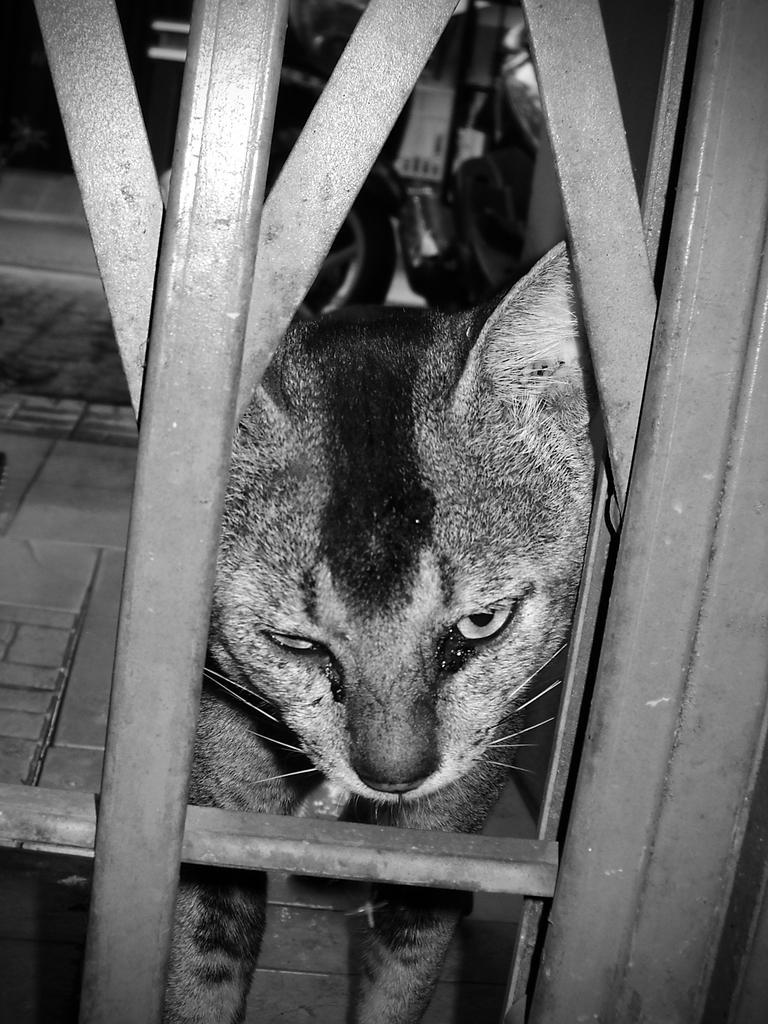Can you describe this image briefly? In the picture we can see a part of the gate from it we can see a cat is looking out. 